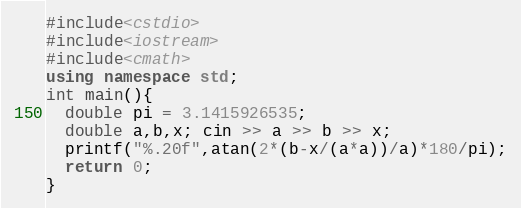<code> <loc_0><loc_0><loc_500><loc_500><_C++_>#include<cstdio>
#include<iostream>
#include<cmath>
using namespace std;
int main(){
  double pi = 3.1415926535;
  double a,b,x; cin >> a >> b >> x;
  printf("%.20f",atan(2*(b-x/(a*a))/a)*180/pi);
  return 0;
}</code> 